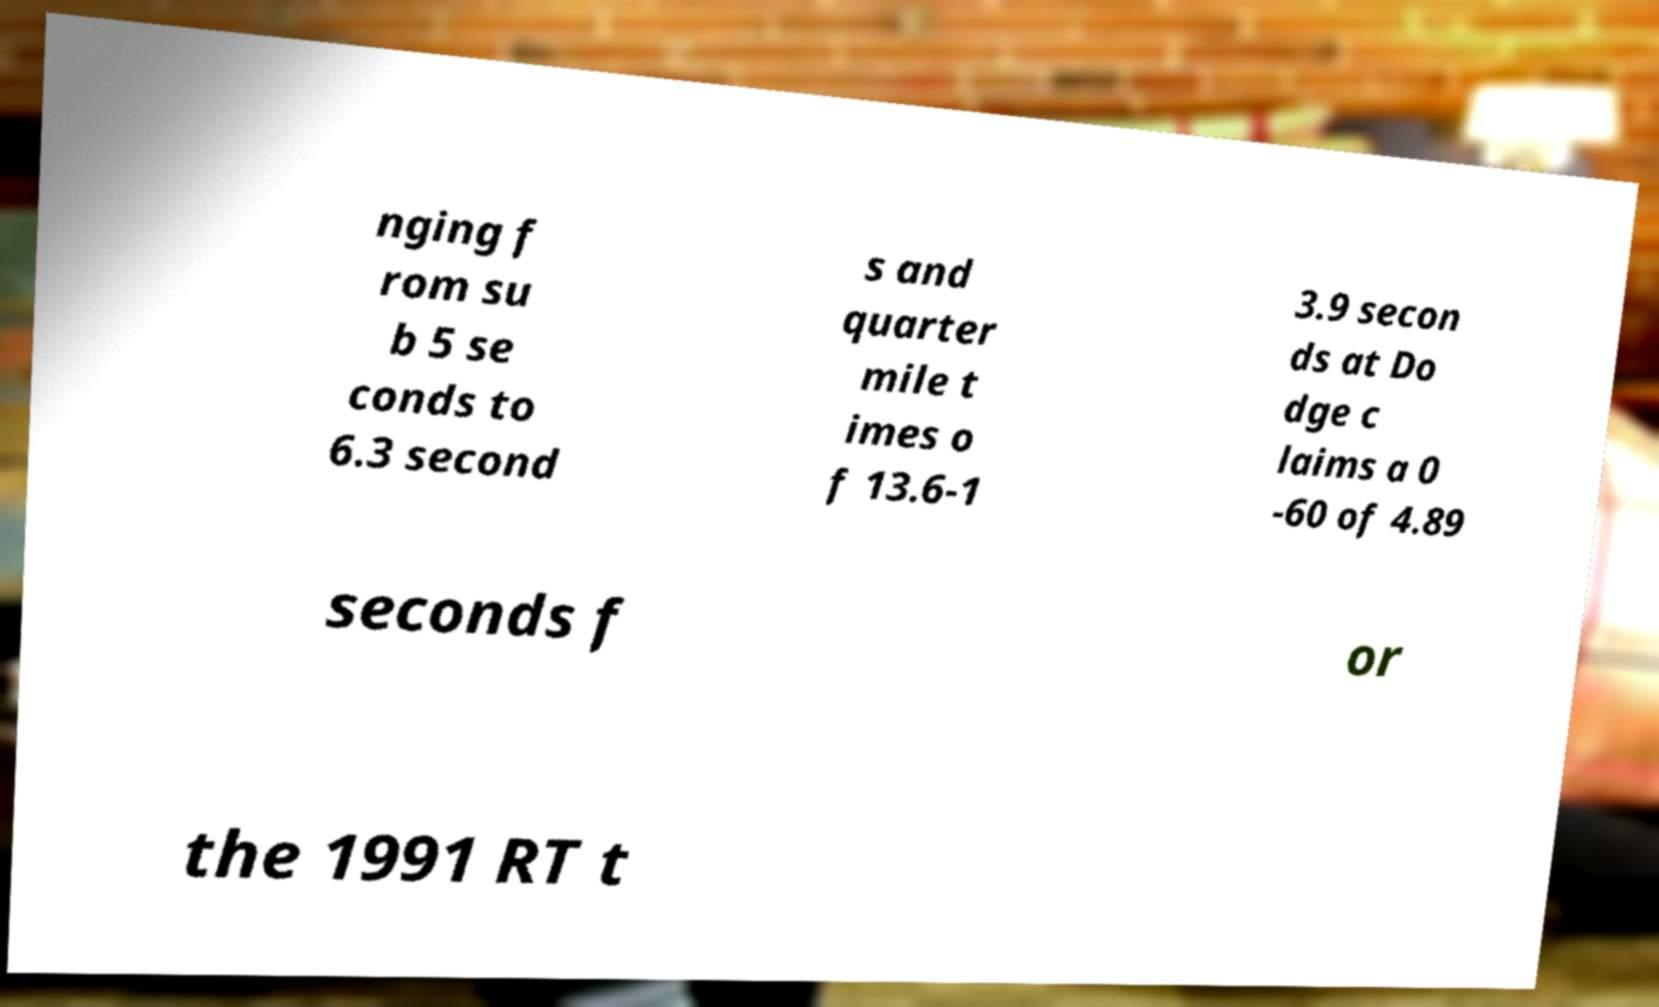I need the written content from this picture converted into text. Can you do that? nging f rom su b 5 se conds to 6.3 second s and quarter mile t imes o f 13.6-1 3.9 secon ds at Do dge c laims a 0 -60 of 4.89 seconds f or the 1991 RT t 